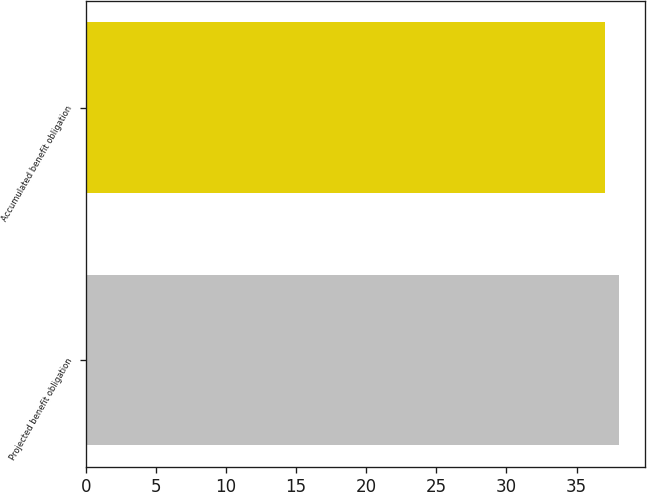Convert chart to OTSL. <chart><loc_0><loc_0><loc_500><loc_500><bar_chart><fcel>Projected benefit obligation<fcel>Accumulated benefit obligation<nl><fcel>38<fcel>37<nl></chart> 